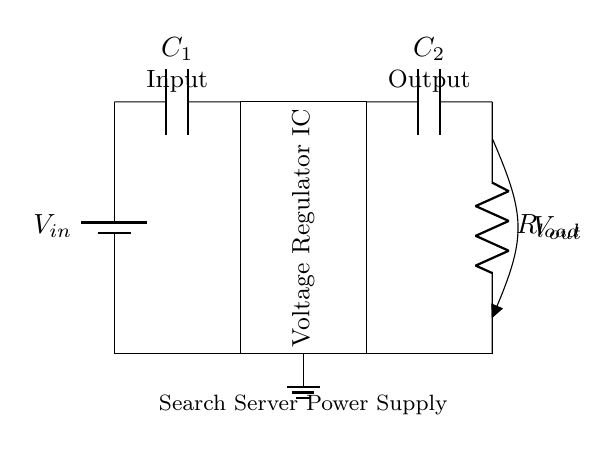What is the input component of the circuit? The input component is the battery, which provides the input voltage to the circuit.
Answer: battery What is the role of capacitor C1 in the circuit? Capacitor C1 is used for filtering and stabilizing the input voltage to the voltage regulator, helping to smooth out any fluctuations.
Answer: filtering What is the purpose of the voltage regulator IC? The voltage regulator IC stabilizes the output voltage to a constant level, ensuring that the load receives a steady voltage regardless of variations in the input voltage or load conditions.
Answer: stabilizes output What is the output voltage labeled in the circuit? The output voltage is labeled as V out, which indicates the voltage provided to the load resistor R load.
Answer: V out How are C2 and R load connected in the circuit? Capacitor C2 is connected in parallel with the load resistor R load, which helps filter the output and provides additional stability under varying load conditions.
Answer: in parallel What type of circuit is represented here? This is a voltage regulation circuit, specifically designed for powering components such as those found in search servers, providing stable voltage for reliable operation.
Answer: voltage regulation circuit 